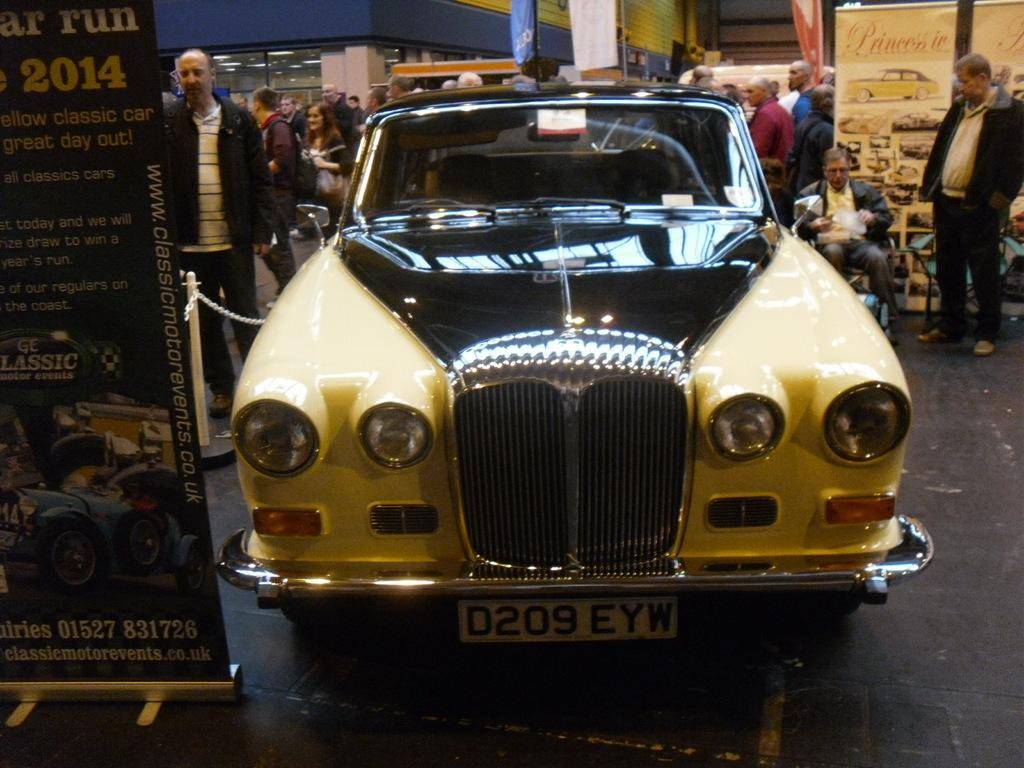<image>
Give a short and clear explanation of the subsequent image. a sign that says 2014 with a car next to it 